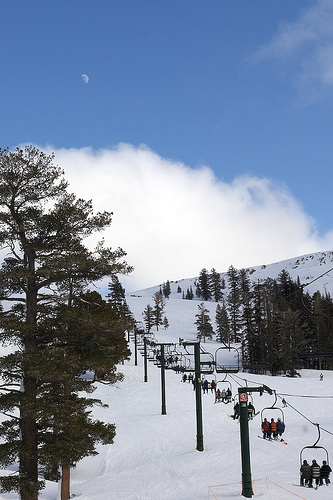<image>
Is there a tree to the right of the tree? Yes. From this viewpoint, the tree is positioned to the right side relative to the tree. 